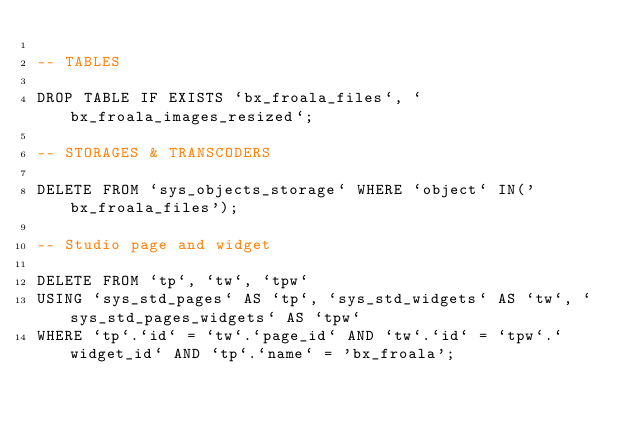<code> <loc_0><loc_0><loc_500><loc_500><_SQL_>
-- TABLES

DROP TABLE IF EXISTS `bx_froala_files`, `bx_froala_images_resized`;

-- STORAGES & TRANSCODERS

DELETE FROM `sys_objects_storage` WHERE `object` IN('bx_froala_files');

-- Studio page and widget

DELETE FROM `tp`, `tw`, `tpw`
USING `sys_std_pages` AS `tp`, `sys_std_widgets` AS `tw`, `sys_std_pages_widgets` AS `tpw`
WHERE `tp`.`id` = `tw`.`page_id` AND `tw`.`id` = `tpw`.`widget_id` AND `tp`.`name` = 'bx_froala';

</code> 